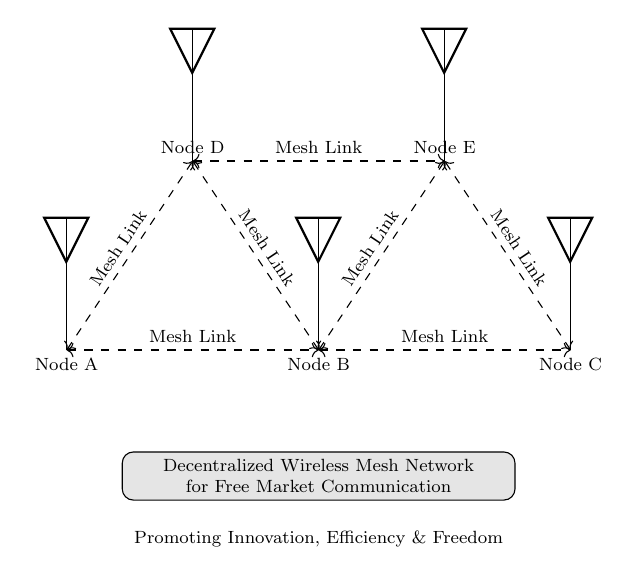What are the nodes labeled in the circuit? The nodes in the circuit are labeled A, B, C, D, and E. These labels are indicated on the circuit diagram next to each antenna symbol.
Answer: A, B, C, D, E How many mesh links are present in the diagram? The diagram shows a total of seven mesh links connecting various nodes. Each dashed line between the antennas represents a mesh link, and counting these shows there are seven.
Answer: Seven Which nodes are directly connected to Node A? Nodes A is directly connected to Nodes B and D, as observed by the dashed lines leading from Node A to these nodes.
Answer: B, D What is the main purpose of the wireless mesh network as indicated in the diagram? The purpose described in the diagram is "Decentralized Wireless Mesh Network for Free Market Communication," which signifies the intent to support communication in a decentralized manner.
Answer: Decentralized wireless mesh network for free market communication Which node connects to both Node D and Node E? Node B connects to both Node D and Node E, as shown by the dashed lines linking these nodes separately to Node B.
Answer: B What does the description at the bottom of the diagram emphasize? The description emphasizes "Promoting Innovation, Efficiency & Freedom," indicating the values that the network aims to support through its decentralized communication approach.
Answer: Promoting innovation, efficiency & freedom 